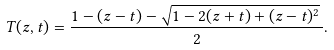Convert formula to latex. <formula><loc_0><loc_0><loc_500><loc_500>T ( z , t ) = \frac { 1 - ( z - t ) - \sqrt { 1 - 2 ( z + t ) + ( z - t ) ^ { 2 } } \, } { 2 } .</formula> 